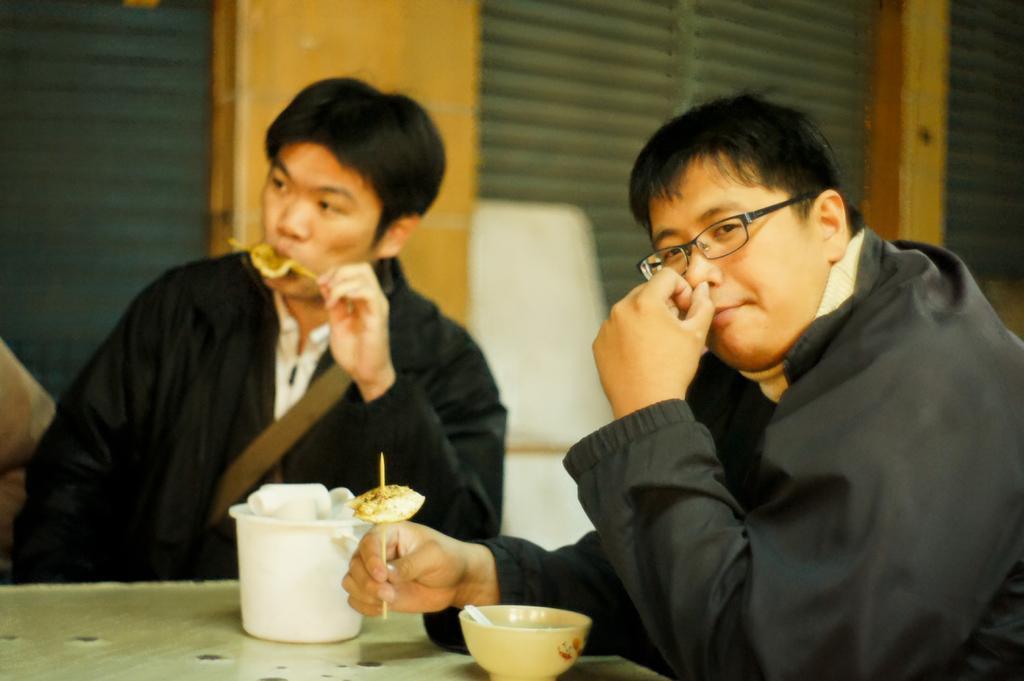Describe this image in one or two sentences. In the foreground of the picture there are two persons, table, bowls and food items. In the background we can see windows and window blinds. 